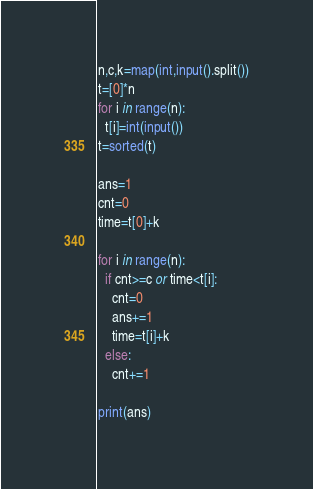Convert code to text. <code><loc_0><loc_0><loc_500><loc_500><_Python_>n,c,k=map(int,input().split())
t=[0]*n
for i in range(n):
  t[i]=int(input())
t=sorted(t)

ans=1
cnt=0
time=t[0]+k

for i in range(n):
  if cnt>=c or time<t[i]:
    cnt=0
    ans+=1
    time=t[i]+k
  else:
    cnt+=1
    
print(ans)</code> 